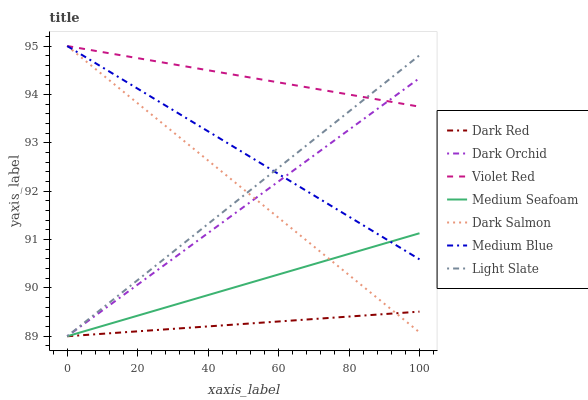Does Dark Red have the minimum area under the curve?
Answer yes or no. Yes. Does Violet Red have the maximum area under the curve?
Answer yes or no. Yes. Does Light Slate have the minimum area under the curve?
Answer yes or no. No. Does Light Slate have the maximum area under the curve?
Answer yes or no. No. Is Violet Red the smoothest?
Answer yes or no. Yes. Is Dark Salmon the roughest?
Answer yes or no. Yes. Is Light Slate the smoothest?
Answer yes or no. No. Is Light Slate the roughest?
Answer yes or no. No. Does Medium Blue have the lowest value?
Answer yes or no. No. Does Dark Salmon have the highest value?
Answer yes or no. Yes. Does Light Slate have the highest value?
Answer yes or no. No. Is Medium Seafoam less than Violet Red?
Answer yes or no. Yes. Is Violet Red greater than Dark Red?
Answer yes or no. Yes. Does Medium Seafoam intersect Violet Red?
Answer yes or no. No. 